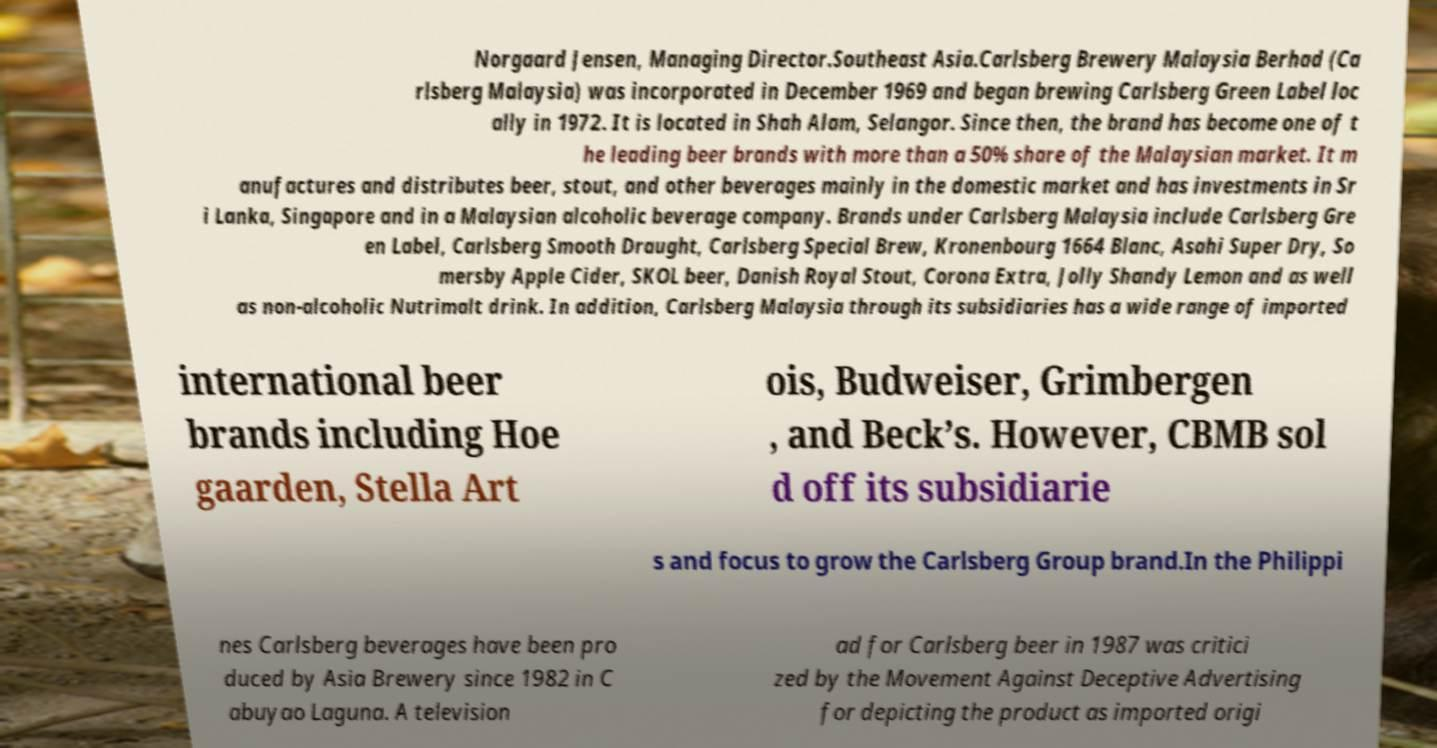Can you accurately transcribe the text from the provided image for me? Norgaard Jensen, Managing Director.Southeast Asia.Carlsberg Brewery Malaysia Berhad (Ca rlsberg Malaysia) was incorporated in December 1969 and began brewing Carlsberg Green Label loc ally in 1972. It is located in Shah Alam, Selangor. Since then, the brand has become one of t he leading beer brands with more than a 50% share of the Malaysian market. It m anufactures and distributes beer, stout, and other beverages mainly in the domestic market and has investments in Sr i Lanka, Singapore and in a Malaysian alcoholic beverage company. Brands under Carlsberg Malaysia include Carlsberg Gre en Label, Carlsberg Smooth Draught, Carlsberg Special Brew, Kronenbourg 1664 Blanc, Asahi Super Dry, So mersby Apple Cider, SKOL beer, Danish Royal Stout, Corona Extra, Jolly Shandy Lemon and as well as non-alcoholic Nutrimalt drink. In addition, Carlsberg Malaysia through its subsidiaries has a wide range of imported international beer brands including Hoe gaarden, Stella Art ois, Budweiser, Grimbergen , and Beck’s. However, CBMB sol d off its subsidiarie s and focus to grow the Carlsberg Group brand.In the Philippi nes Carlsberg beverages have been pro duced by Asia Brewery since 1982 in C abuyao Laguna. A television ad for Carlsberg beer in 1987 was critici zed by the Movement Against Deceptive Advertising for depicting the product as imported origi 